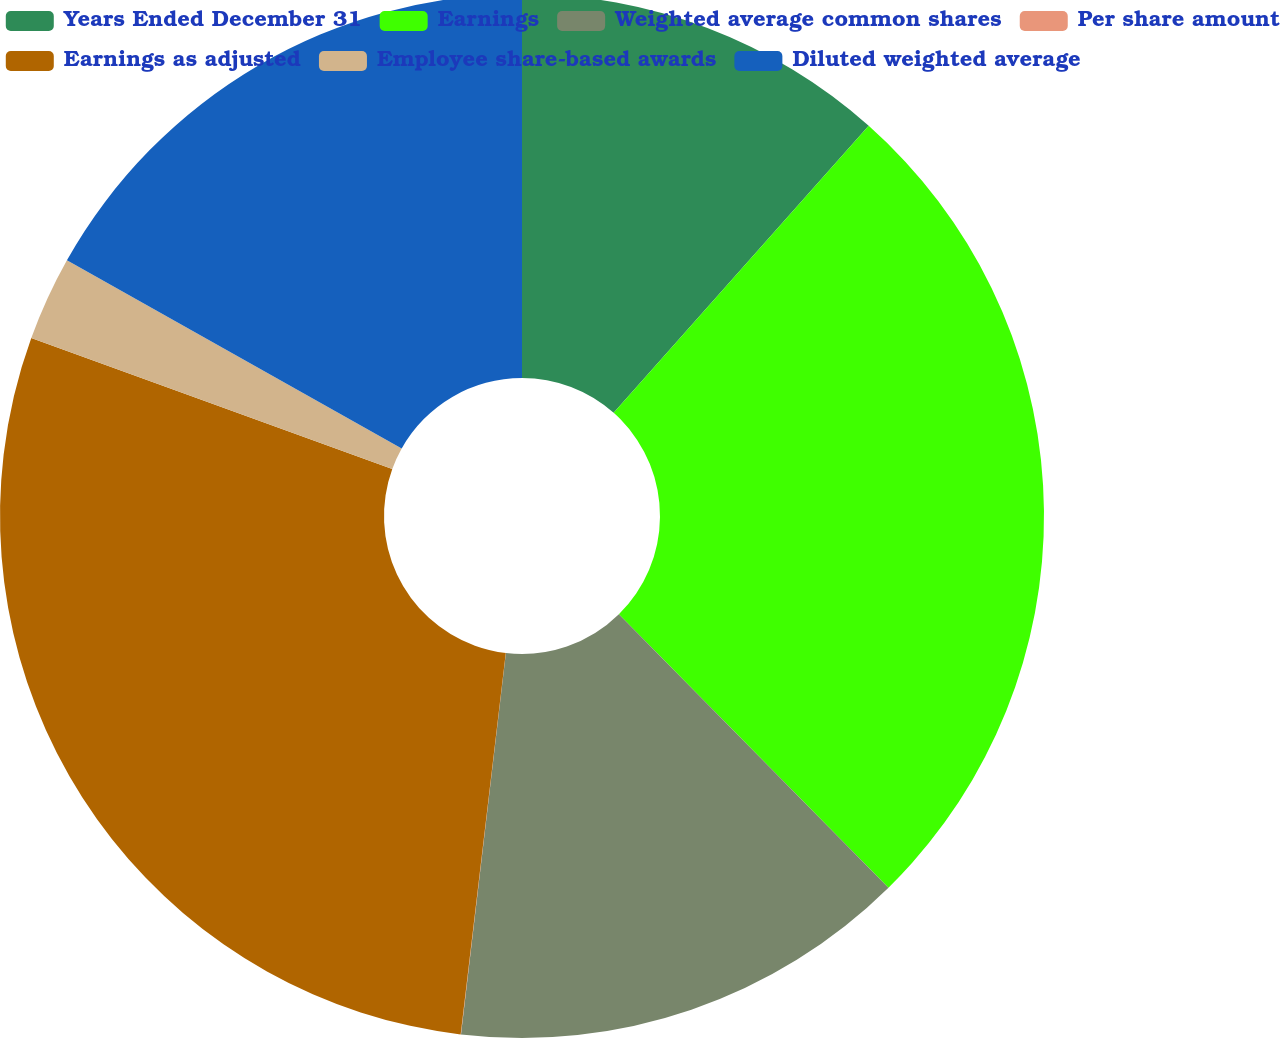<chart> <loc_0><loc_0><loc_500><loc_500><pie_chart><fcel>Years Ended December 31<fcel>Earnings<fcel>Weighted average common shares<fcel>Per share amount<fcel>Earnings as adjusted<fcel>Employee share-based awards<fcel>Diluted weighted average<nl><fcel>11.56%<fcel>26.05%<fcel>14.25%<fcel>0.01%<fcel>28.66%<fcel>2.61%<fcel>16.85%<nl></chart> 